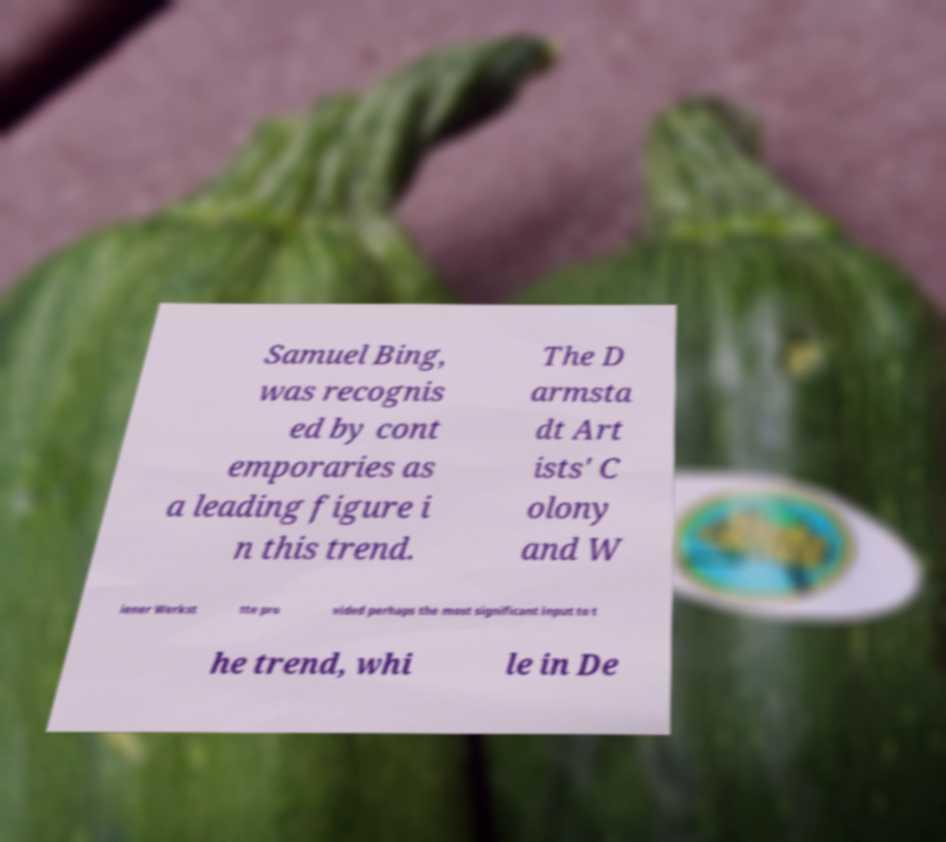Can you accurately transcribe the text from the provided image for me? Samuel Bing, was recognis ed by cont emporaries as a leading figure i n this trend. The D armsta dt Art ists' C olony and W iener Werkst tte pro vided perhaps the most significant input to t he trend, whi le in De 